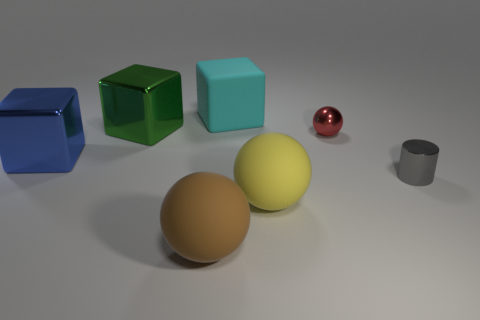Add 1 small purple shiny cylinders. How many objects exist? 8 Subtract all big shiny blocks. How many blocks are left? 1 Subtract 1 blocks. How many blocks are left? 2 Subtract all cylinders. How many objects are left? 6 Add 7 cylinders. How many cylinders exist? 8 Subtract 0 blue cylinders. How many objects are left? 7 Subtract all large brown balls. Subtract all brown blocks. How many objects are left? 6 Add 4 blue shiny objects. How many blue shiny objects are left? 5 